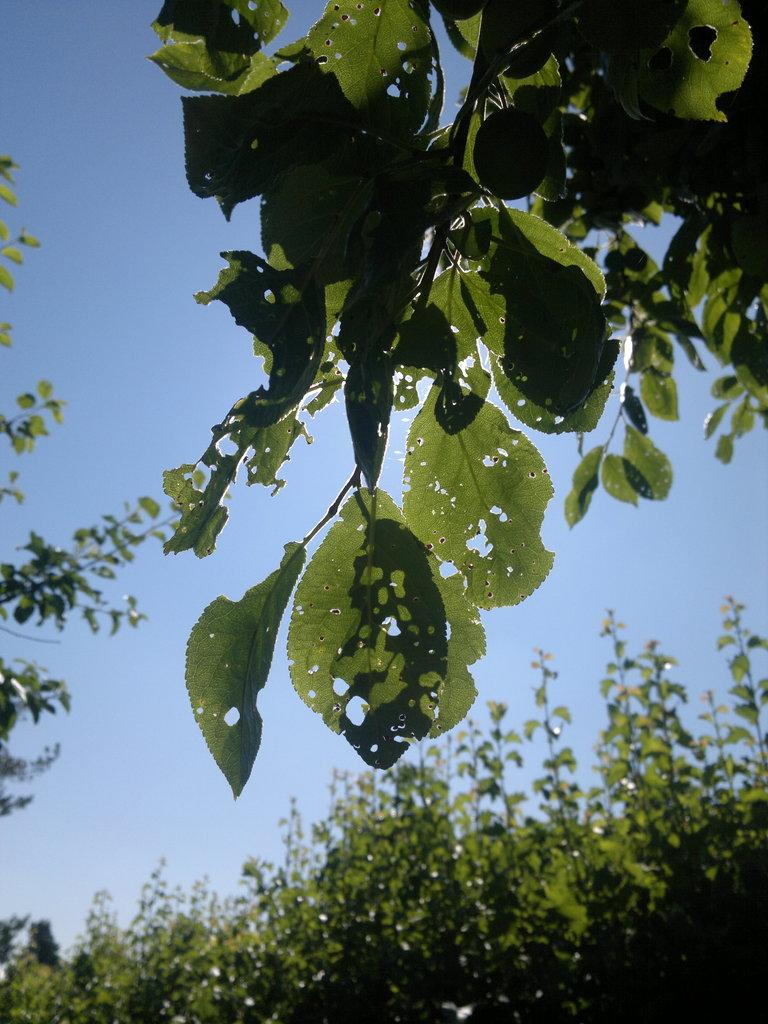What can be seen in the sky in the image? There is sky visible in the image. What type of vegetation is present in the image? There are green leaves and plants in the image. What songs are being sung by the plants in the image? There are no songs being sung by the plants in the image, as plants do not have the ability to sing songs. Can you see any skateboards or rings in the image? There are no skateboards or rings present in the image. 